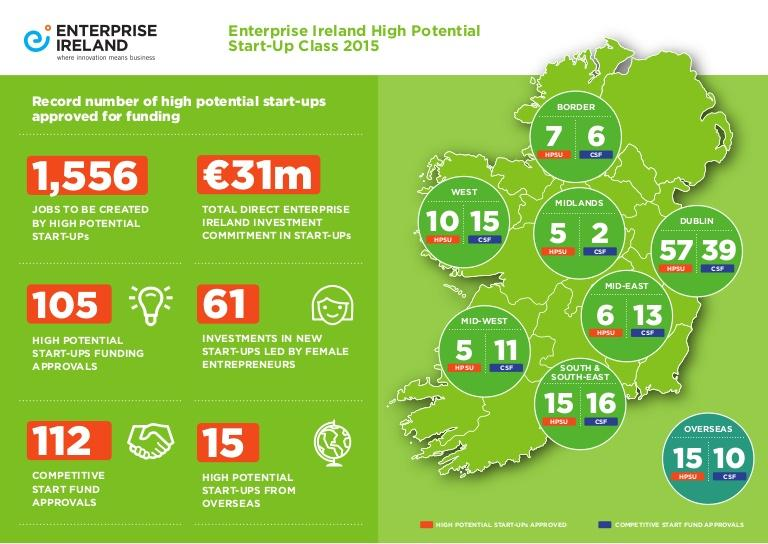Outline some significant characteristics in this image. In 2015, a total of 39 competitive start-ups were approved for funding in Dublin, the capital city of Ireland. In 2015, a total of 112 competitive start fund approvals were done in Ireland. In 2015, ten competitive start fund approvals for start-up companies in Ireland were granted to overseas applicants. In 2015, a total of 105 high-potential start-ups were approved for funding in Ireland. In 2015, five high potential start-ups were approved for funding in the Midland region of Ireland. 